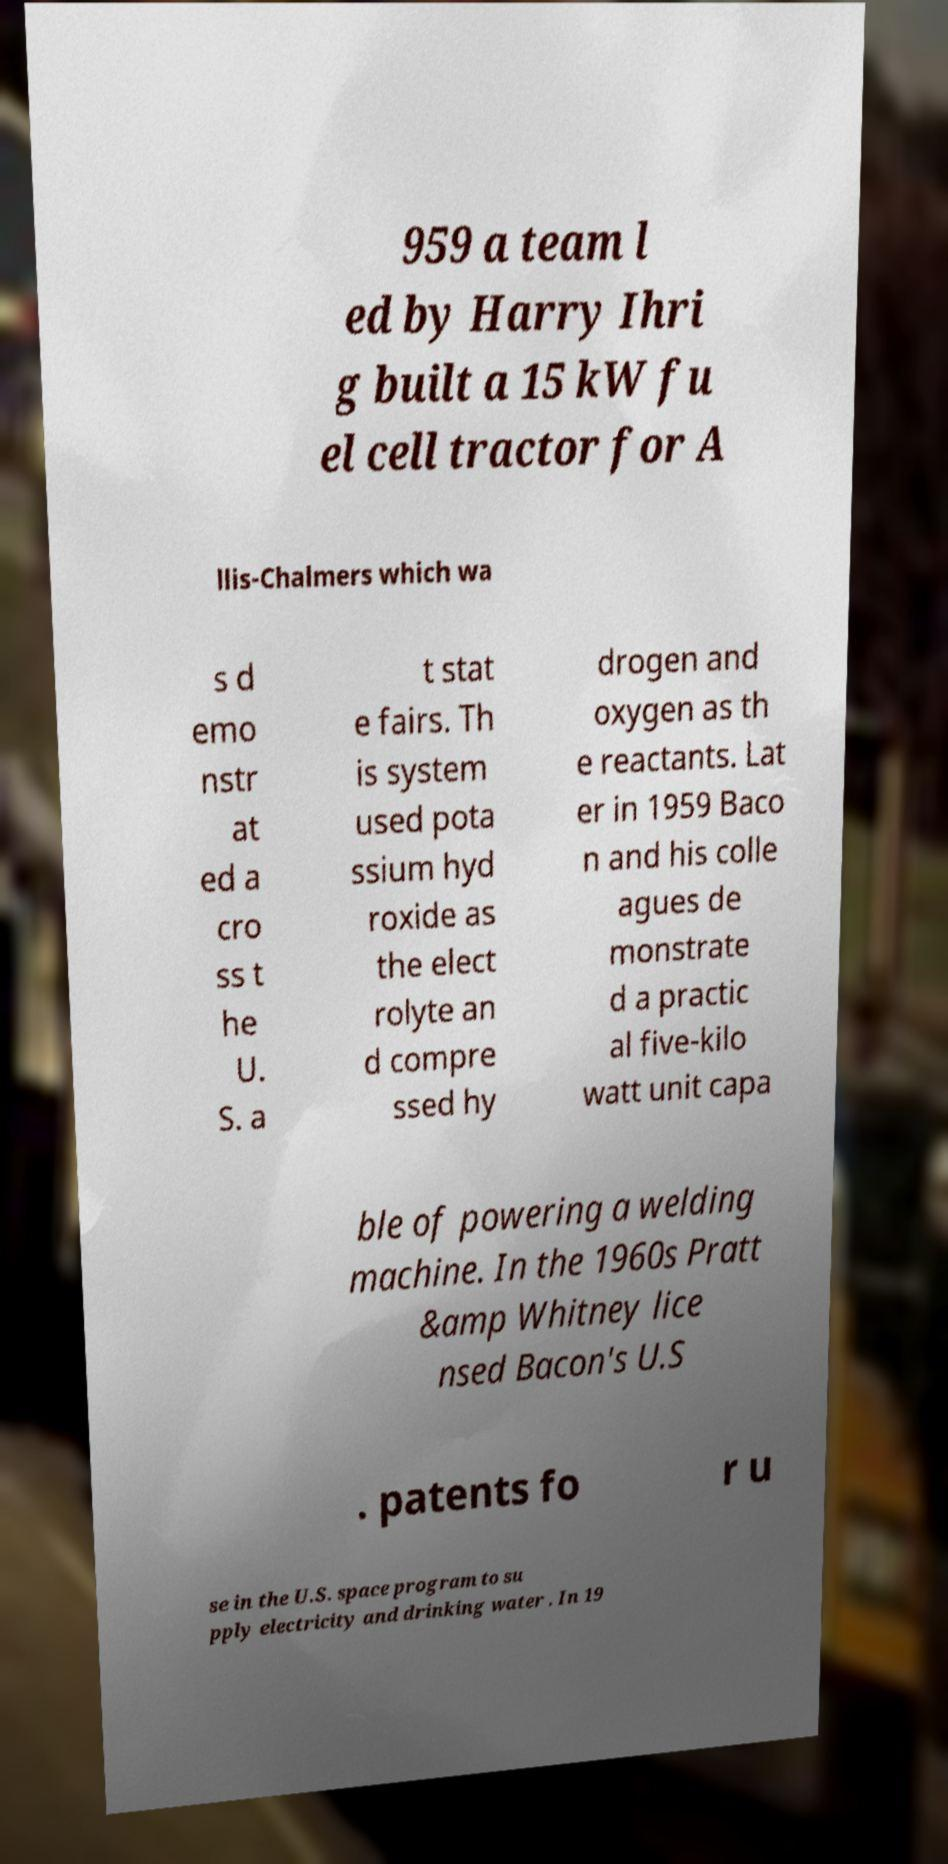Could you assist in decoding the text presented in this image and type it out clearly? 959 a team l ed by Harry Ihri g built a 15 kW fu el cell tractor for A llis-Chalmers which wa s d emo nstr at ed a cro ss t he U. S. a t stat e fairs. Th is system used pota ssium hyd roxide as the elect rolyte an d compre ssed hy drogen and oxygen as th e reactants. Lat er in 1959 Baco n and his colle agues de monstrate d a practic al five-kilo watt unit capa ble of powering a welding machine. In the 1960s Pratt &amp Whitney lice nsed Bacon's U.S . patents fo r u se in the U.S. space program to su pply electricity and drinking water . In 19 